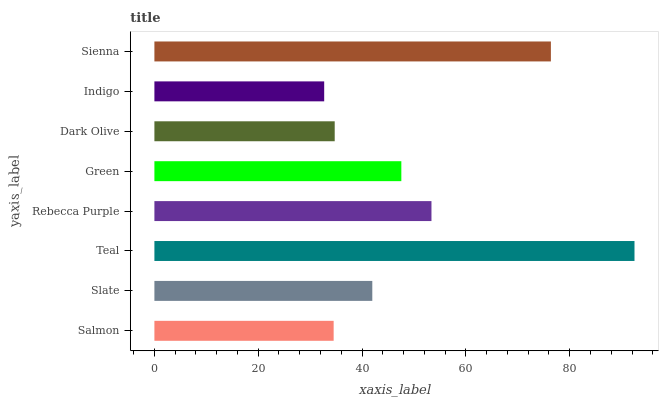Is Indigo the minimum?
Answer yes or no. Yes. Is Teal the maximum?
Answer yes or no. Yes. Is Slate the minimum?
Answer yes or no. No. Is Slate the maximum?
Answer yes or no. No. Is Slate greater than Salmon?
Answer yes or no. Yes. Is Salmon less than Slate?
Answer yes or no. Yes. Is Salmon greater than Slate?
Answer yes or no. No. Is Slate less than Salmon?
Answer yes or no. No. Is Green the high median?
Answer yes or no. Yes. Is Slate the low median?
Answer yes or no. Yes. Is Indigo the high median?
Answer yes or no. No. Is Green the low median?
Answer yes or no. No. 